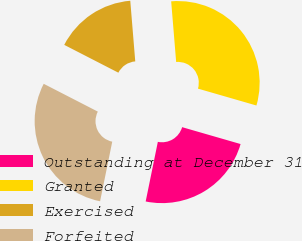Convert chart. <chart><loc_0><loc_0><loc_500><loc_500><pie_chart><fcel>Outstanding at December 31<fcel>Granted<fcel>Exercised<fcel>Forfeited<nl><fcel>23.73%<fcel>30.78%<fcel>16.14%<fcel>29.35%<nl></chart> 